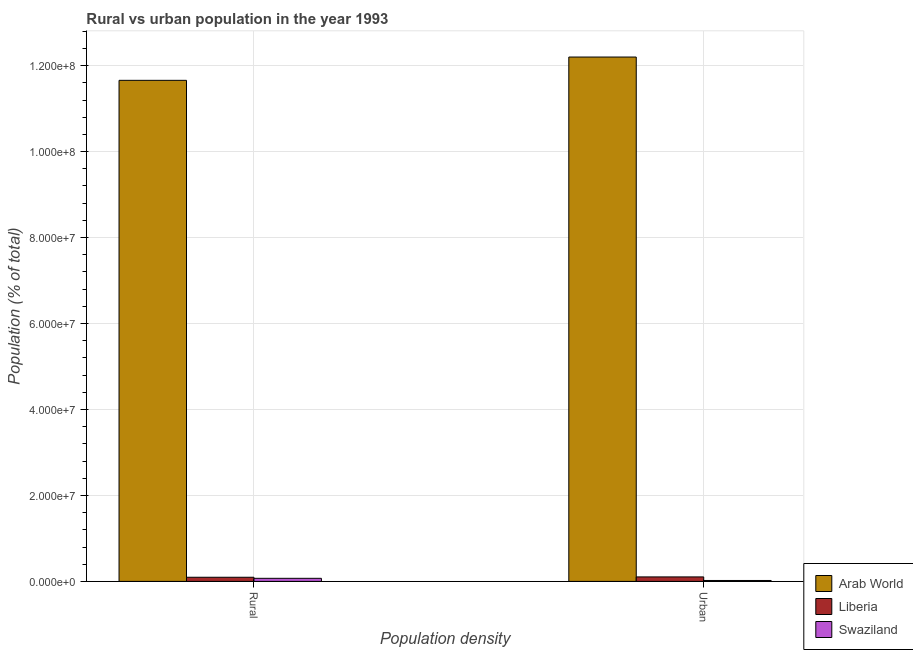Are the number of bars on each tick of the X-axis equal?
Your answer should be very brief. Yes. What is the label of the 2nd group of bars from the left?
Give a very brief answer. Urban. What is the rural population density in Liberia?
Ensure brevity in your answer.  9.63e+05. Across all countries, what is the maximum urban population density?
Your answer should be compact. 1.22e+08. Across all countries, what is the minimum rural population density?
Provide a short and direct response. 7.13e+05. In which country was the rural population density maximum?
Your answer should be compact. Arab World. In which country was the urban population density minimum?
Keep it short and to the point. Swaziland. What is the total urban population density in the graph?
Your answer should be compact. 1.23e+08. What is the difference between the rural population density in Liberia and that in Swaziland?
Ensure brevity in your answer.  2.50e+05. What is the difference between the rural population density in Liberia and the urban population density in Swaziland?
Your answer should be very brief. 7.50e+05. What is the average rural population density per country?
Give a very brief answer. 3.94e+07. What is the difference between the rural population density and urban population density in Swaziland?
Offer a very short reply. 5.00e+05. What is the ratio of the rural population density in Liberia to that in Swaziland?
Offer a terse response. 1.35. What does the 1st bar from the left in Urban represents?
Your answer should be very brief. Arab World. What does the 2nd bar from the right in Urban represents?
Make the answer very short. Liberia. How many bars are there?
Your answer should be very brief. 6. Are all the bars in the graph horizontal?
Provide a succinct answer. No. Does the graph contain any zero values?
Ensure brevity in your answer.  No. Does the graph contain grids?
Provide a succinct answer. Yes. Where does the legend appear in the graph?
Your answer should be very brief. Bottom right. What is the title of the graph?
Offer a terse response. Rural vs urban population in the year 1993. What is the label or title of the X-axis?
Ensure brevity in your answer.  Population density. What is the label or title of the Y-axis?
Offer a terse response. Population (% of total). What is the Population (% of total) of Arab World in Rural?
Your answer should be compact. 1.17e+08. What is the Population (% of total) in Liberia in Rural?
Ensure brevity in your answer.  9.63e+05. What is the Population (% of total) of Swaziland in Rural?
Your answer should be very brief. 7.13e+05. What is the Population (% of total) in Arab World in Urban?
Offer a very short reply. 1.22e+08. What is the Population (% of total) in Liberia in Urban?
Offer a very short reply. 1.04e+06. What is the Population (% of total) in Swaziland in Urban?
Provide a succinct answer. 2.13e+05. Across all Population density, what is the maximum Population (% of total) in Arab World?
Your answer should be very brief. 1.22e+08. Across all Population density, what is the maximum Population (% of total) in Liberia?
Provide a succinct answer. 1.04e+06. Across all Population density, what is the maximum Population (% of total) of Swaziland?
Provide a succinct answer. 7.13e+05. Across all Population density, what is the minimum Population (% of total) of Arab World?
Provide a succinct answer. 1.17e+08. Across all Population density, what is the minimum Population (% of total) of Liberia?
Offer a very short reply. 9.63e+05. Across all Population density, what is the minimum Population (% of total) in Swaziland?
Give a very brief answer. 2.13e+05. What is the total Population (% of total) in Arab World in the graph?
Give a very brief answer. 2.39e+08. What is the total Population (% of total) in Liberia in the graph?
Offer a terse response. 2.01e+06. What is the total Population (% of total) of Swaziland in the graph?
Keep it short and to the point. 9.26e+05. What is the difference between the Population (% of total) in Arab World in Rural and that in Urban?
Your response must be concise. -5.42e+06. What is the difference between the Population (% of total) of Liberia in Rural and that in Urban?
Offer a very short reply. -8.06e+04. What is the difference between the Population (% of total) of Swaziland in Rural and that in Urban?
Provide a short and direct response. 5.00e+05. What is the difference between the Population (% of total) of Arab World in Rural and the Population (% of total) of Liberia in Urban?
Offer a very short reply. 1.16e+08. What is the difference between the Population (% of total) in Arab World in Rural and the Population (% of total) in Swaziland in Urban?
Your answer should be compact. 1.16e+08. What is the difference between the Population (% of total) in Liberia in Rural and the Population (% of total) in Swaziland in Urban?
Your response must be concise. 7.50e+05. What is the average Population (% of total) of Arab World per Population density?
Keep it short and to the point. 1.19e+08. What is the average Population (% of total) in Liberia per Population density?
Keep it short and to the point. 1.00e+06. What is the average Population (% of total) in Swaziland per Population density?
Offer a terse response. 4.63e+05. What is the difference between the Population (% of total) in Arab World and Population (% of total) in Liberia in Rural?
Your response must be concise. 1.16e+08. What is the difference between the Population (% of total) in Arab World and Population (% of total) in Swaziland in Rural?
Keep it short and to the point. 1.16e+08. What is the difference between the Population (% of total) in Liberia and Population (% of total) in Swaziland in Rural?
Your response must be concise. 2.50e+05. What is the difference between the Population (% of total) of Arab World and Population (% of total) of Liberia in Urban?
Provide a succinct answer. 1.21e+08. What is the difference between the Population (% of total) in Arab World and Population (% of total) in Swaziland in Urban?
Provide a short and direct response. 1.22e+08. What is the difference between the Population (% of total) of Liberia and Population (% of total) of Swaziland in Urban?
Ensure brevity in your answer.  8.31e+05. What is the ratio of the Population (% of total) in Arab World in Rural to that in Urban?
Offer a terse response. 0.96. What is the ratio of the Population (% of total) in Liberia in Rural to that in Urban?
Your answer should be very brief. 0.92. What is the ratio of the Population (% of total) in Swaziland in Rural to that in Urban?
Give a very brief answer. 3.35. What is the difference between the highest and the second highest Population (% of total) of Arab World?
Offer a very short reply. 5.42e+06. What is the difference between the highest and the second highest Population (% of total) in Liberia?
Your answer should be compact. 8.06e+04. What is the difference between the highest and the second highest Population (% of total) in Swaziland?
Offer a terse response. 5.00e+05. What is the difference between the highest and the lowest Population (% of total) in Arab World?
Provide a succinct answer. 5.42e+06. What is the difference between the highest and the lowest Population (% of total) in Liberia?
Offer a very short reply. 8.06e+04. What is the difference between the highest and the lowest Population (% of total) in Swaziland?
Ensure brevity in your answer.  5.00e+05. 